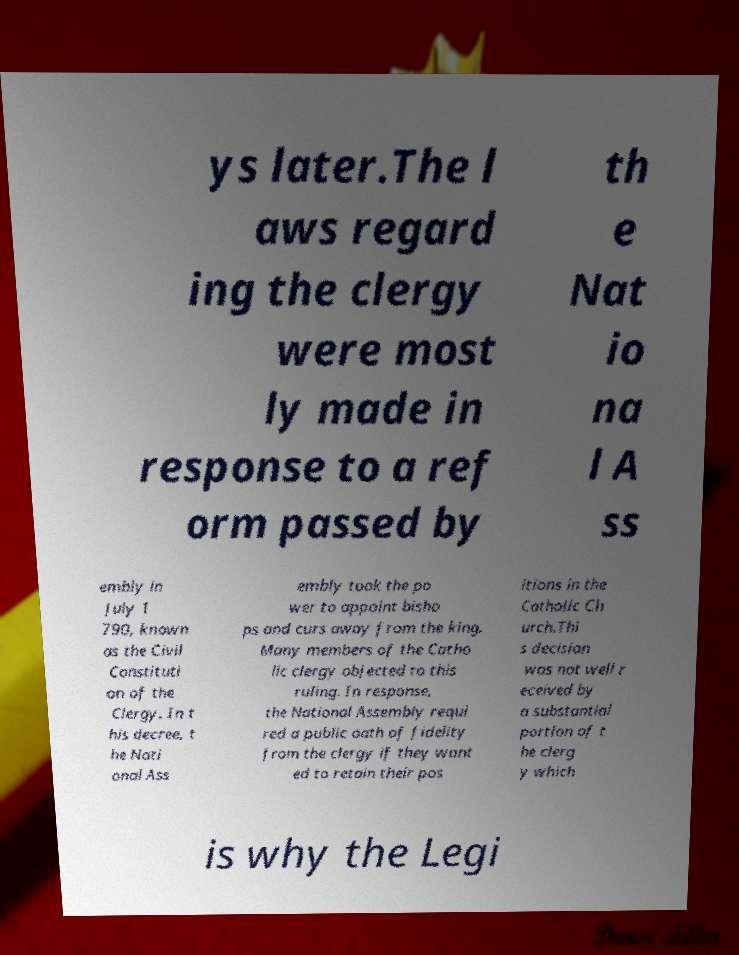What messages or text are displayed in this image? I need them in a readable, typed format. ys later.The l aws regard ing the clergy were most ly made in response to a ref orm passed by th e Nat io na l A ss embly in July 1 790, known as the Civil Constituti on of the Clergy. In t his decree, t he Nati onal Ass embly took the po wer to appoint bisho ps and curs away from the king. Many members of the Catho lic clergy objected to this ruling. In response, the National Assembly requi red a public oath of fidelity from the clergy if they want ed to retain their pos itions in the Catholic Ch urch.Thi s decision was not well r eceived by a substantial portion of t he clerg y which is why the Legi 